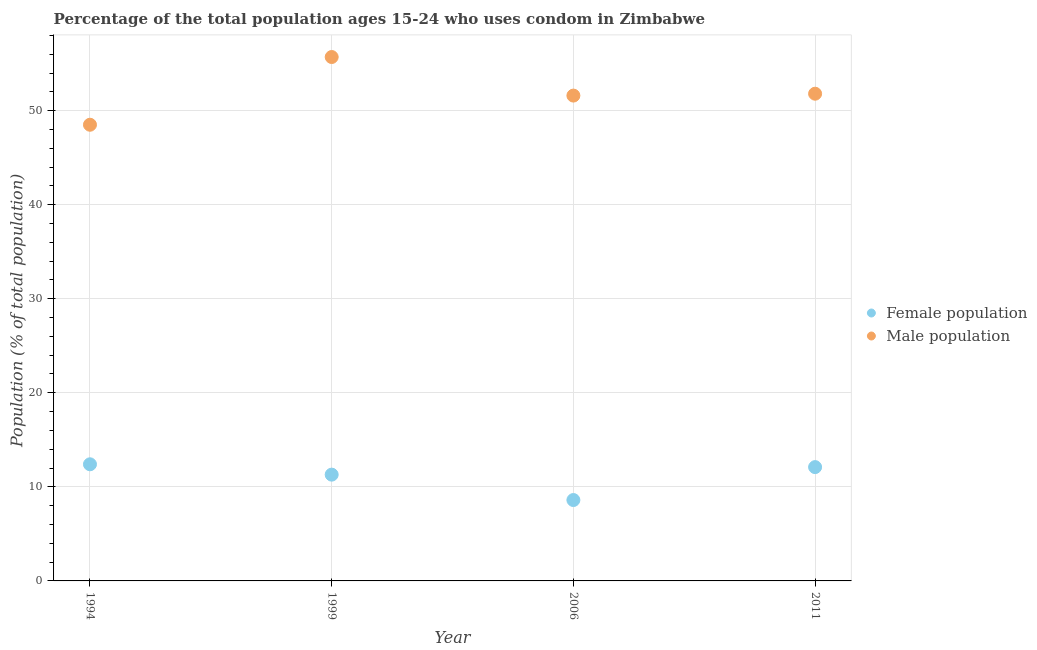How many different coloured dotlines are there?
Your response must be concise. 2. Is the number of dotlines equal to the number of legend labels?
Provide a short and direct response. Yes. What is the female population in 1994?
Provide a succinct answer. 12.4. Across all years, what is the minimum male population?
Ensure brevity in your answer.  48.5. In which year was the female population maximum?
Offer a very short reply. 1994. What is the total female population in the graph?
Provide a succinct answer. 44.4. What is the difference between the male population in 1994 and that in 1999?
Give a very brief answer. -7.2. What is the difference between the male population in 2011 and the female population in 1999?
Give a very brief answer. 40.5. What is the average male population per year?
Keep it short and to the point. 51.9. What is the ratio of the female population in 1994 to that in 2006?
Your answer should be compact. 1.44. Is the female population in 1994 less than that in 2011?
Ensure brevity in your answer.  No. Is the difference between the male population in 1994 and 2011 greater than the difference between the female population in 1994 and 2011?
Your response must be concise. No. What is the difference between the highest and the second highest female population?
Provide a short and direct response. 0.3. What is the difference between the highest and the lowest male population?
Give a very brief answer. 7.2. In how many years, is the male population greater than the average male population taken over all years?
Make the answer very short. 1. Does the female population monotonically increase over the years?
Offer a terse response. No. Is the male population strictly less than the female population over the years?
Offer a very short reply. No. How many dotlines are there?
Ensure brevity in your answer.  2. How many years are there in the graph?
Your response must be concise. 4. Are the values on the major ticks of Y-axis written in scientific E-notation?
Provide a succinct answer. No. Does the graph contain grids?
Give a very brief answer. Yes. What is the title of the graph?
Your response must be concise. Percentage of the total population ages 15-24 who uses condom in Zimbabwe. What is the label or title of the Y-axis?
Offer a very short reply. Population (% of total population) . What is the Population (% of total population)  of Male population in 1994?
Your answer should be very brief. 48.5. What is the Population (% of total population)  of Female population in 1999?
Provide a short and direct response. 11.3. What is the Population (% of total population)  of Male population in 1999?
Provide a short and direct response. 55.7. What is the Population (% of total population)  of Male population in 2006?
Your response must be concise. 51.6. What is the Population (% of total population)  in Female population in 2011?
Make the answer very short. 12.1. What is the Population (% of total population)  of Male population in 2011?
Provide a short and direct response. 51.8. Across all years, what is the maximum Population (% of total population)  in Female population?
Provide a short and direct response. 12.4. Across all years, what is the maximum Population (% of total population)  of Male population?
Ensure brevity in your answer.  55.7. Across all years, what is the minimum Population (% of total population)  of Male population?
Ensure brevity in your answer.  48.5. What is the total Population (% of total population)  in Female population in the graph?
Give a very brief answer. 44.4. What is the total Population (% of total population)  in Male population in the graph?
Provide a short and direct response. 207.6. What is the difference between the Population (% of total population)  of Female population in 1994 and that in 1999?
Ensure brevity in your answer.  1.1. What is the difference between the Population (% of total population)  in Male population in 1994 and that in 1999?
Your answer should be compact. -7.2. What is the difference between the Population (% of total population)  of Female population in 1994 and that in 2006?
Make the answer very short. 3.8. What is the difference between the Population (% of total population)  of Male population in 1994 and that in 2006?
Ensure brevity in your answer.  -3.1. What is the difference between the Population (% of total population)  of Female population in 1994 and that in 2011?
Give a very brief answer. 0.3. What is the difference between the Population (% of total population)  in Male population in 1994 and that in 2011?
Offer a terse response. -3.3. What is the difference between the Population (% of total population)  of Female population in 1999 and that in 2006?
Your answer should be compact. 2.7. What is the difference between the Population (% of total population)  in Female population in 1999 and that in 2011?
Make the answer very short. -0.8. What is the difference between the Population (% of total population)  in Male population in 2006 and that in 2011?
Ensure brevity in your answer.  -0.2. What is the difference between the Population (% of total population)  of Female population in 1994 and the Population (% of total population)  of Male population in 1999?
Ensure brevity in your answer.  -43.3. What is the difference between the Population (% of total population)  of Female population in 1994 and the Population (% of total population)  of Male population in 2006?
Ensure brevity in your answer.  -39.2. What is the difference between the Population (% of total population)  in Female population in 1994 and the Population (% of total population)  in Male population in 2011?
Provide a short and direct response. -39.4. What is the difference between the Population (% of total population)  in Female population in 1999 and the Population (% of total population)  in Male population in 2006?
Your response must be concise. -40.3. What is the difference between the Population (% of total population)  of Female population in 1999 and the Population (% of total population)  of Male population in 2011?
Offer a terse response. -40.5. What is the difference between the Population (% of total population)  of Female population in 2006 and the Population (% of total population)  of Male population in 2011?
Keep it short and to the point. -43.2. What is the average Population (% of total population)  in Female population per year?
Offer a very short reply. 11.1. What is the average Population (% of total population)  of Male population per year?
Provide a succinct answer. 51.9. In the year 1994, what is the difference between the Population (% of total population)  of Female population and Population (% of total population)  of Male population?
Ensure brevity in your answer.  -36.1. In the year 1999, what is the difference between the Population (% of total population)  in Female population and Population (% of total population)  in Male population?
Make the answer very short. -44.4. In the year 2006, what is the difference between the Population (% of total population)  in Female population and Population (% of total population)  in Male population?
Offer a terse response. -43. In the year 2011, what is the difference between the Population (% of total population)  in Female population and Population (% of total population)  in Male population?
Offer a terse response. -39.7. What is the ratio of the Population (% of total population)  in Female population in 1994 to that in 1999?
Keep it short and to the point. 1.1. What is the ratio of the Population (% of total population)  of Male population in 1994 to that in 1999?
Keep it short and to the point. 0.87. What is the ratio of the Population (% of total population)  of Female population in 1994 to that in 2006?
Offer a terse response. 1.44. What is the ratio of the Population (% of total population)  in Male population in 1994 to that in 2006?
Your answer should be compact. 0.94. What is the ratio of the Population (% of total population)  of Female population in 1994 to that in 2011?
Offer a terse response. 1.02. What is the ratio of the Population (% of total population)  in Male population in 1994 to that in 2011?
Ensure brevity in your answer.  0.94. What is the ratio of the Population (% of total population)  in Female population in 1999 to that in 2006?
Ensure brevity in your answer.  1.31. What is the ratio of the Population (% of total population)  in Male population in 1999 to that in 2006?
Offer a terse response. 1.08. What is the ratio of the Population (% of total population)  in Female population in 1999 to that in 2011?
Keep it short and to the point. 0.93. What is the ratio of the Population (% of total population)  of Male population in 1999 to that in 2011?
Your answer should be very brief. 1.08. What is the ratio of the Population (% of total population)  in Female population in 2006 to that in 2011?
Keep it short and to the point. 0.71. What is the difference between the highest and the second highest Population (% of total population)  in Female population?
Your answer should be compact. 0.3. What is the difference between the highest and the second highest Population (% of total population)  in Male population?
Ensure brevity in your answer.  3.9. 